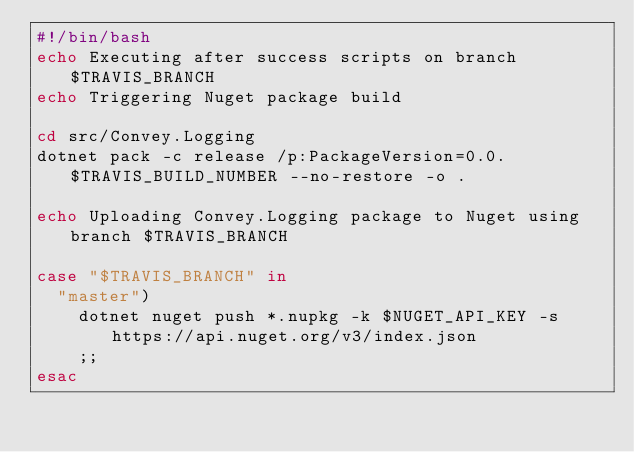Convert code to text. <code><loc_0><loc_0><loc_500><loc_500><_Bash_>#!/bin/bash
echo Executing after success scripts on branch $TRAVIS_BRANCH
echo Triggering Nuget package build

cd src/Convey.Logging
dotnet pack -c release /p:PackageVersion=0.0.$TRAVIS_BUILD_NUMBER --no-restore -o .

echo Uploading Convey.Logging package to Nuget using branch $TRAVIS_BRANCH

case "$TRAVIS_BRANCH" in
  "master")
    dotnet nuget push *.nupkg -k $NUGET_API_KEY -s https://api.nuget.org/v3/index.json
    ;;
esac</code> 